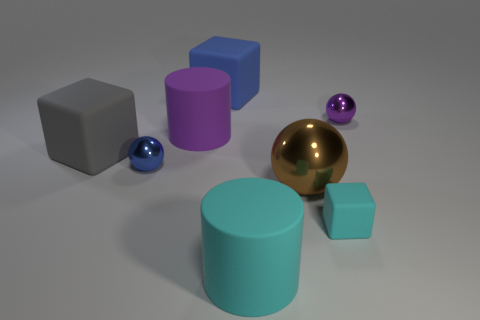Add 1 big cyan cylinders. How many objects exist? 9 Subtract all large matte blocks. How many blocks are left? 1 Subtract 3 spheres. How many spheres are left? 0 Subtract all big brown metal objects. Subtract all big cylinders. How many objects are left? 5 Add 5 rubber objects. How many rubber objects are left? 10 Add 2 green rubber objects. How many green rubber objects exist? 2 Subtract all cyan cylinders. How many cylinders are left? 1 Subtract 1 cyan blocks. How many objects are left? 7 Subtract all cylinders. How many objects are left? 6 Subtract all green blocks. Subtract all green cylinders. How many blocks are left? 3 